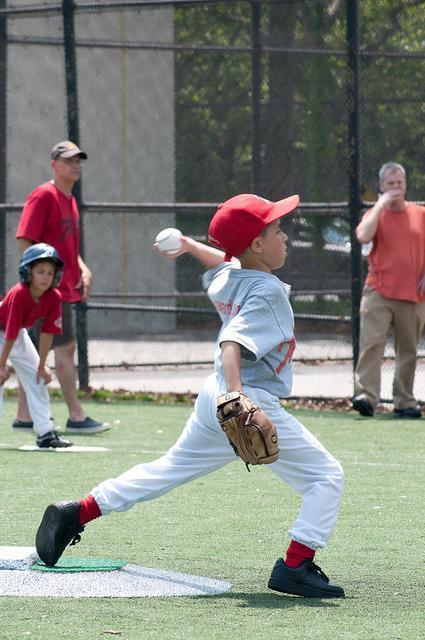How many people are in the picture?
Give a very brief answer. 4. 